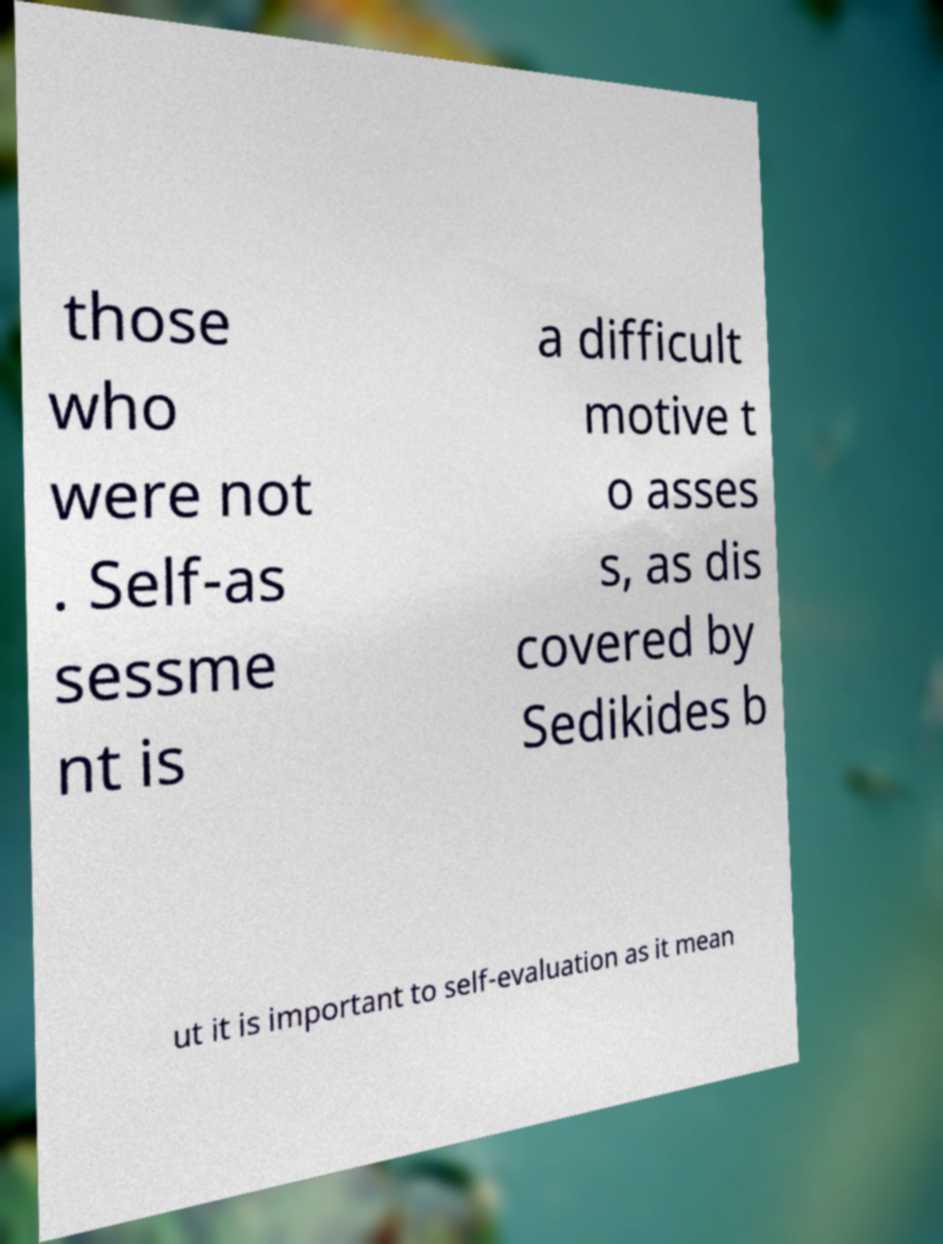There's text embedded in this image that I need extracted. Can you transcribe it verbatim? those who were not . Self-as sessme nt is a difficult motive t o asses s, as dis covered by Sedikides b ut it is important to self-evaluation as it mean 